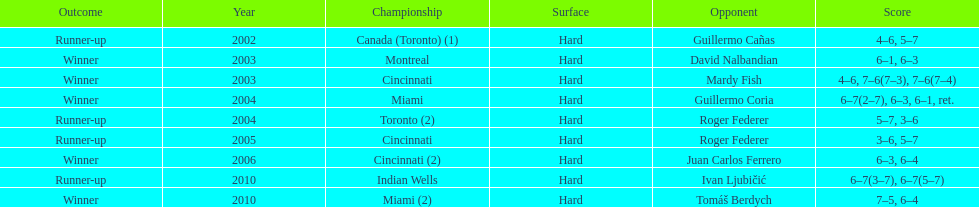How many occasions was the championship in miami? 2. 